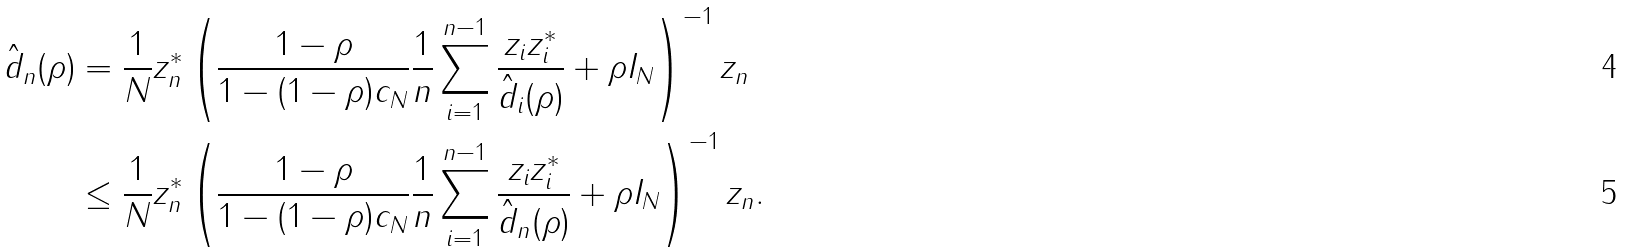<formula> <loc_0><loc_0><loc_500><loc_500>\hat { d } _ { n } ( \rho ) & = \frac { 1 } { N } z _ { n } ^ { * } \left ( \frac { 1 - \rho } { 1 - ( 1 - \rho ) c _ { N } } \frac { 1 } { n } \sum _ { i = 1 } ^ { n - 1 } \frac { z _ { i } z _ { i } ^ { * } } { \hat { d } _ { i } ( \rho ) } + \rho I _ { N } \right ) ^ { - 1 } z _ { n } \\ & \leq \frac { 1 } { N } z _ { n } ^ { * } \left ( \frac { 1 - \rho } { 1 - ( 1 - \rho ) c _ { N } } \frac { 1 } { n } \sum _ { i = 1 } ^ { n - 1 } \frac { z _ { i } z _ { i } ^ { * } } { \hat { d } _ { n } ( \rho ) } + \rho I _ { N } \right ) ^ { - 1 } z _ { n } .</formula> 